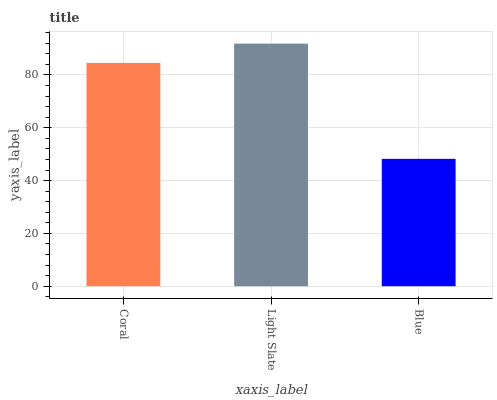Is Blue the minimum?
Answer yes or no. Yes. Is Light Slate the maximum?
Answer yes or no. Yes. Is Light Slate the minimum?
Answer yes or no. No. Is Blue the maximum?
Answer yes or no. No. Is Light Slate greater than Blue?
Answer yes or no. Yes. Is Blue less than Light Slate?
Answer yes or no. Yes. Is Blue greater than Light Slate?
Answer yes or no. No. Is Light Slate less than Blue?
Answer yes or no. No. Is Coral the high median?
Answer yes or no. Yes. Is Coral the low median?
Answer yes or no. Yes. Is Blue the high median?
Answer yes or no. No. Is Light Slate the low median?
Answer yes or no. No. 